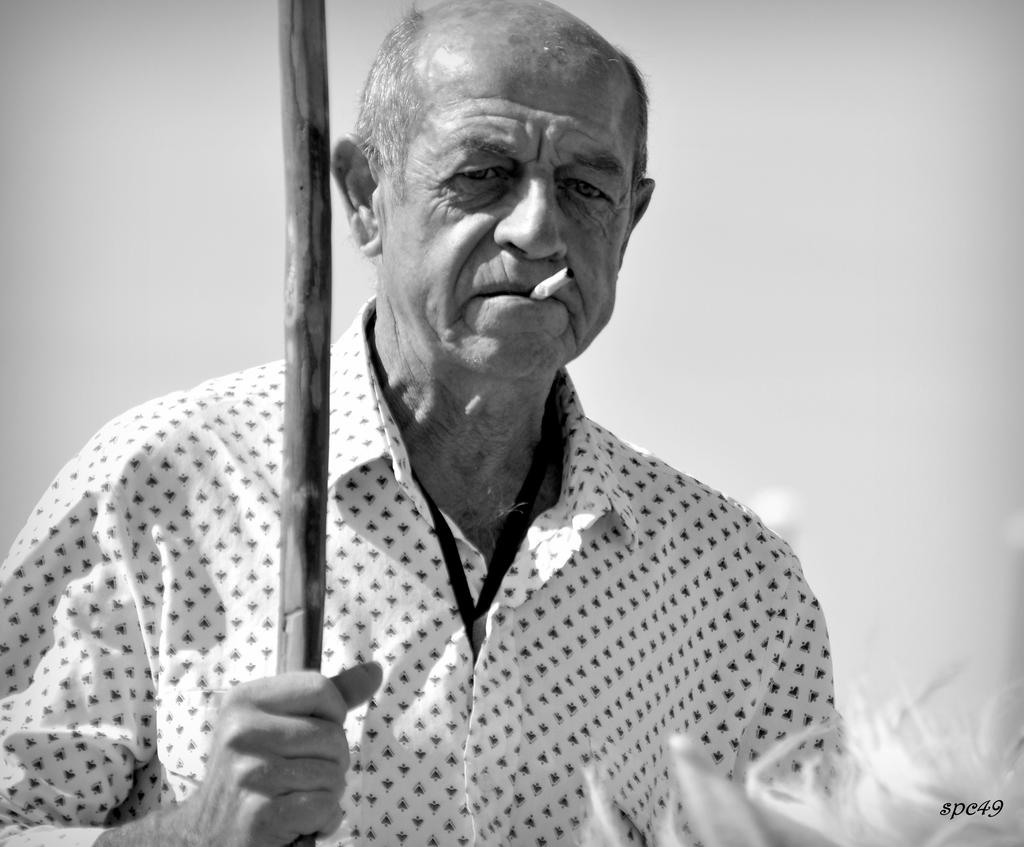What is the color scheme of the image? The image is black and white. Can you describe the person in the image? There is a person in the image. What is the person holding in the image? The person is holding a stick. Is there any additional information or branding on the image? Yes, there is a watermark on the image. What type of jewel is the person wearing on their wrist in the image? There is no jewel visible on the person's wrist in the image. How does the person adjust the stick's length in the image? The image does not show the person adjusting the stick's length, as it is a still image. 